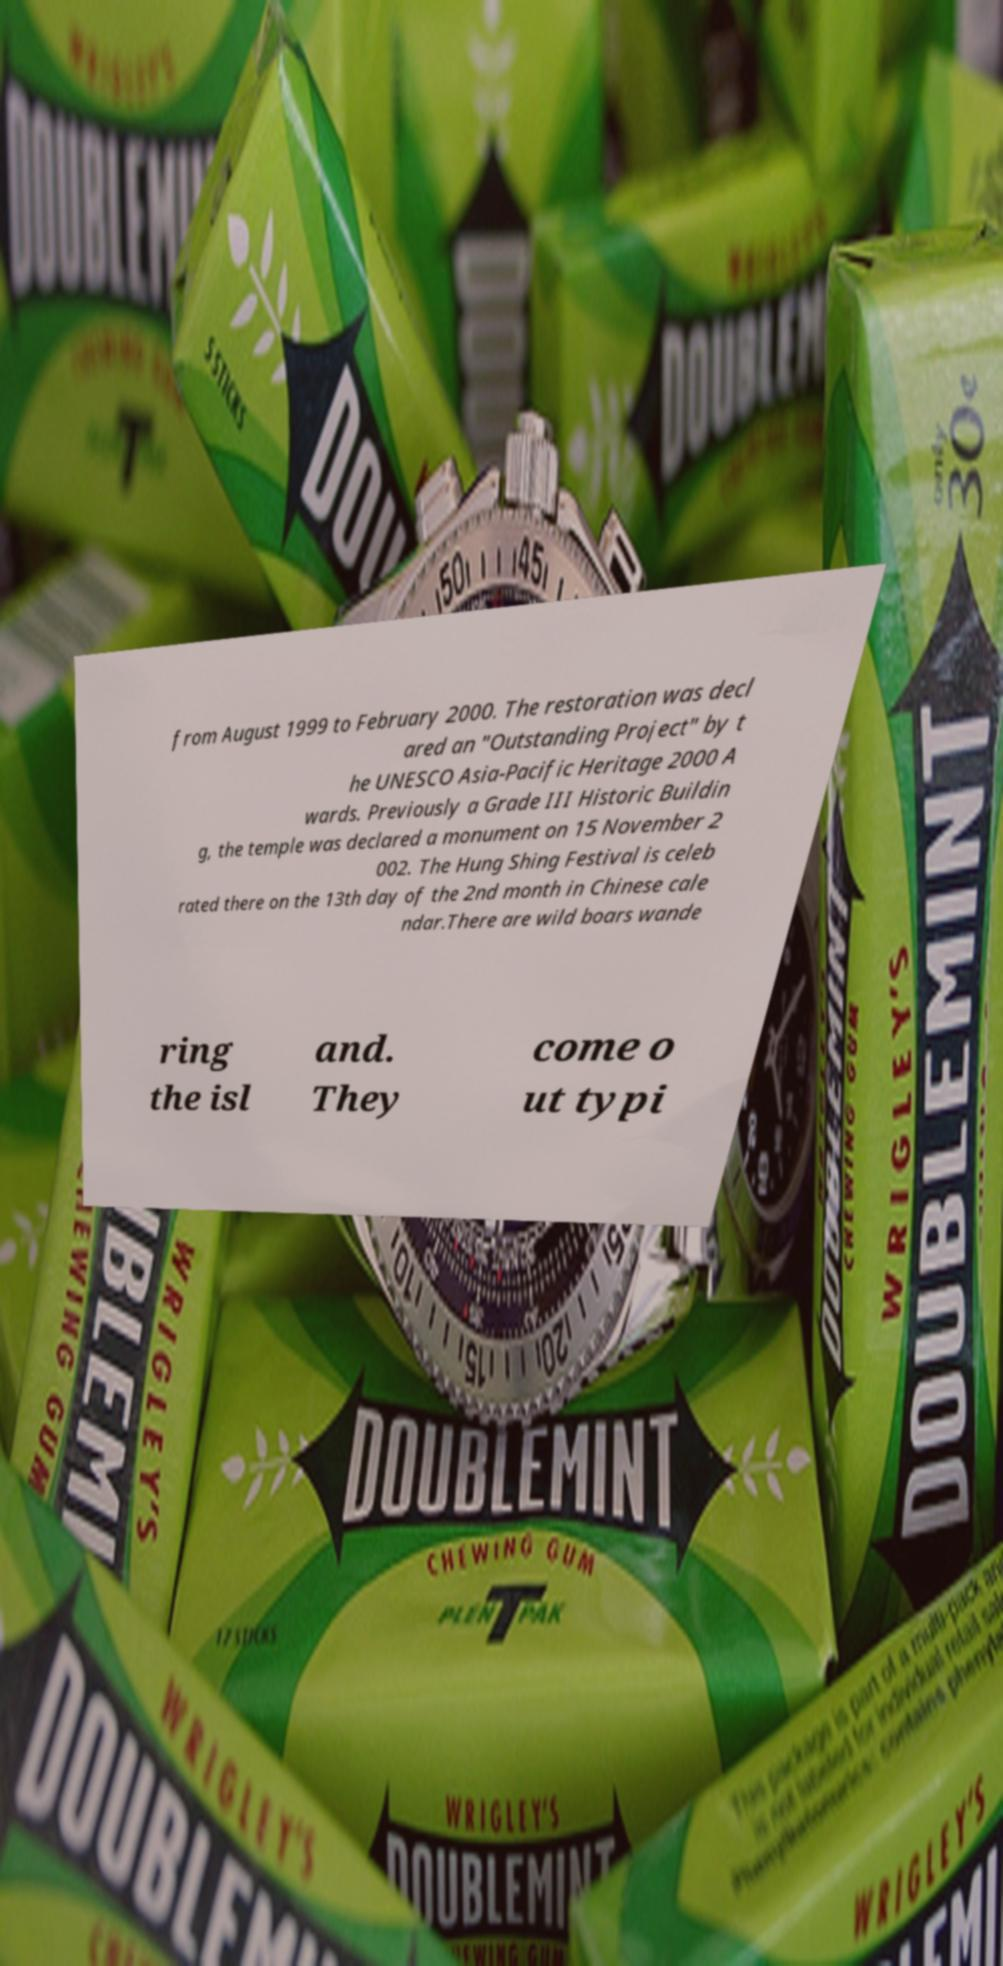Can you read and provide the text displayed in the image?This photo seems to have some interesting text. Can you extract and type it out for me? from August 1999 to February 2000. The restoration was decl ared an "Outstanding Project" by t he UNESCO Asia-Pacific Heritage 2000 A wards. Previously a Grade III Historic Buildin g, the temple was declared a monument on 15 November 2 002. The Hung Shing Festival is celeb rated there on the 13th day of the 2nd month in Chinese cale ndar.There are wild boars wande ring the isl and. They come o ut typi 